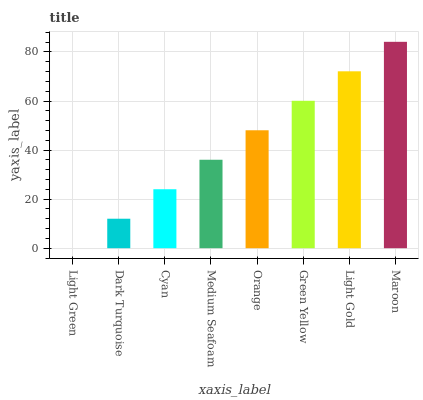Is Light Green the minimum?
Answer yes or no. Yes. Is Maroon the maximum?
Answer yes or no. Yes. Is Dark Turquoise the minimum?
Answer yes or no. No. Is Dark Turquoise the maximum?
Answer yes or no. No. Is Dark Turquoise greater than Light Green?
Answer yes or no. Yes. Is Light Green less than Dark Turquoise?
Answer yes or no. Yes. Is Light Green greater than Dark Turquoise?
Answer yes or no. No. Is Dark Turquoise less than Light Green?
Answer yes or no. No. Is Orange the high median?
Answer yes or no. Yes. Is Medium Seafoam the low median?
Answer yes or no. Yes. Is Light Green the high median?
Answer yes or no. No. Is Light Green the low median?
Answer yes or no. No. 